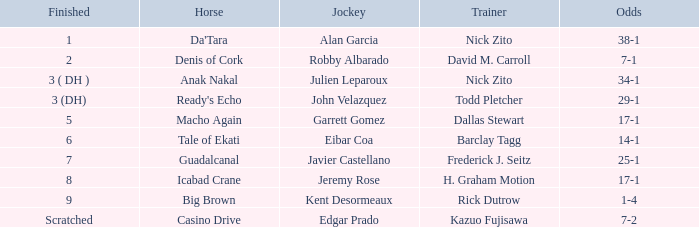What is the final placement for da'tara coached by nick zito? 1.0. 